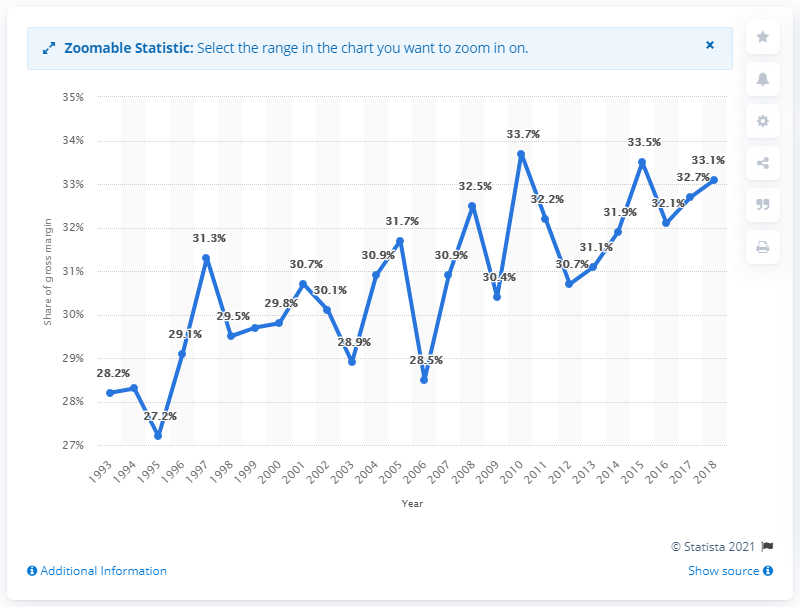Point out several critical features in this image. In 2018, the gross margin's share of sales of apparel, piece goods, and notions in the U.S. wholesale industry was 33.1%. 